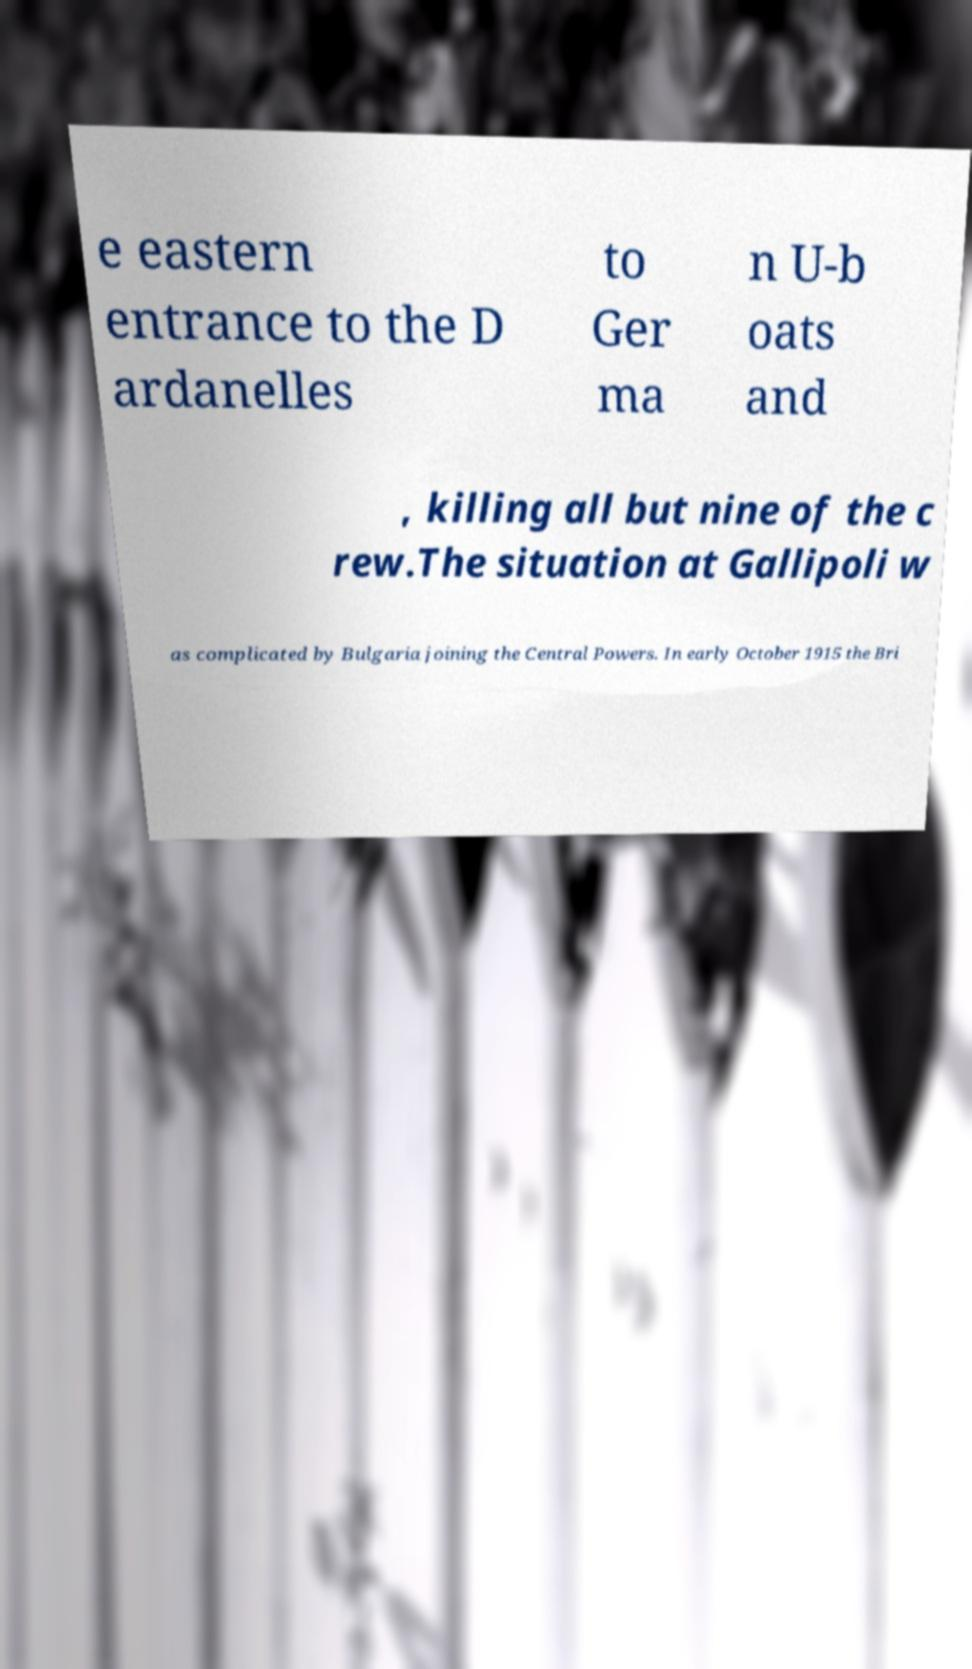Could you extract and type out the text from this image? e eastern entrance to the D ardanelles to Ger ma n U-b oats and , killing all but nine of the c rew.The situation at Gallipoli w as complicated by Bulgaria joining the Central Powers. In early October 1915 the Bri 